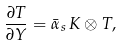Convert formula to latex. <formula><loc_0><loc_0><loc_500><loc_500>\frac { \partial T } { \partial Y } = \bar { \alpha } _ { s } \, K \otimes T ,</formula> 